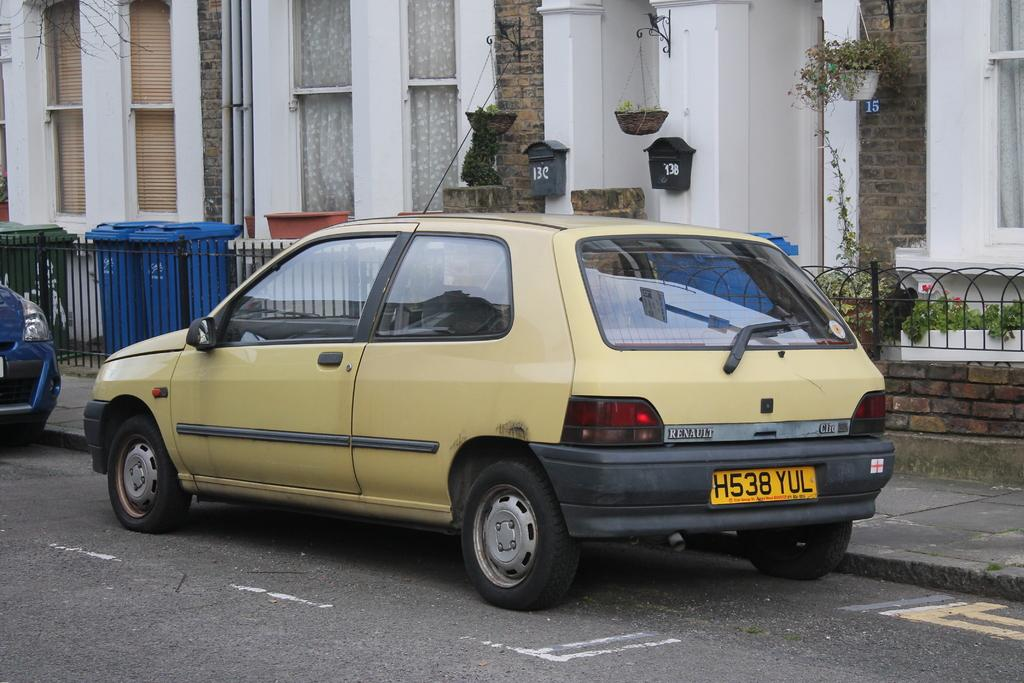What can be seen on the road in the image? There are vehicles on the road in the image. What type of structures are visible in the image? There are buildings in the image. What part of the buildings can be seen in the image? Windows are visible in the image. What objects are present for holding plants? Flowerpots are present in the image. What are the objects used for waste disposal in the image? Dustbins are visible in the image. What type of vegetation is present in the image? Plants are present in the image. What type of barrier is visible in the image? Fencing is visible in the image. What objects are used for mailing purposes in the image? There are post boxes on the wall in the image. How does the bubble affect the distribution of vehicles in the image? There is no bubble present in the image, so it cannot affect the distribution of vehicles. 